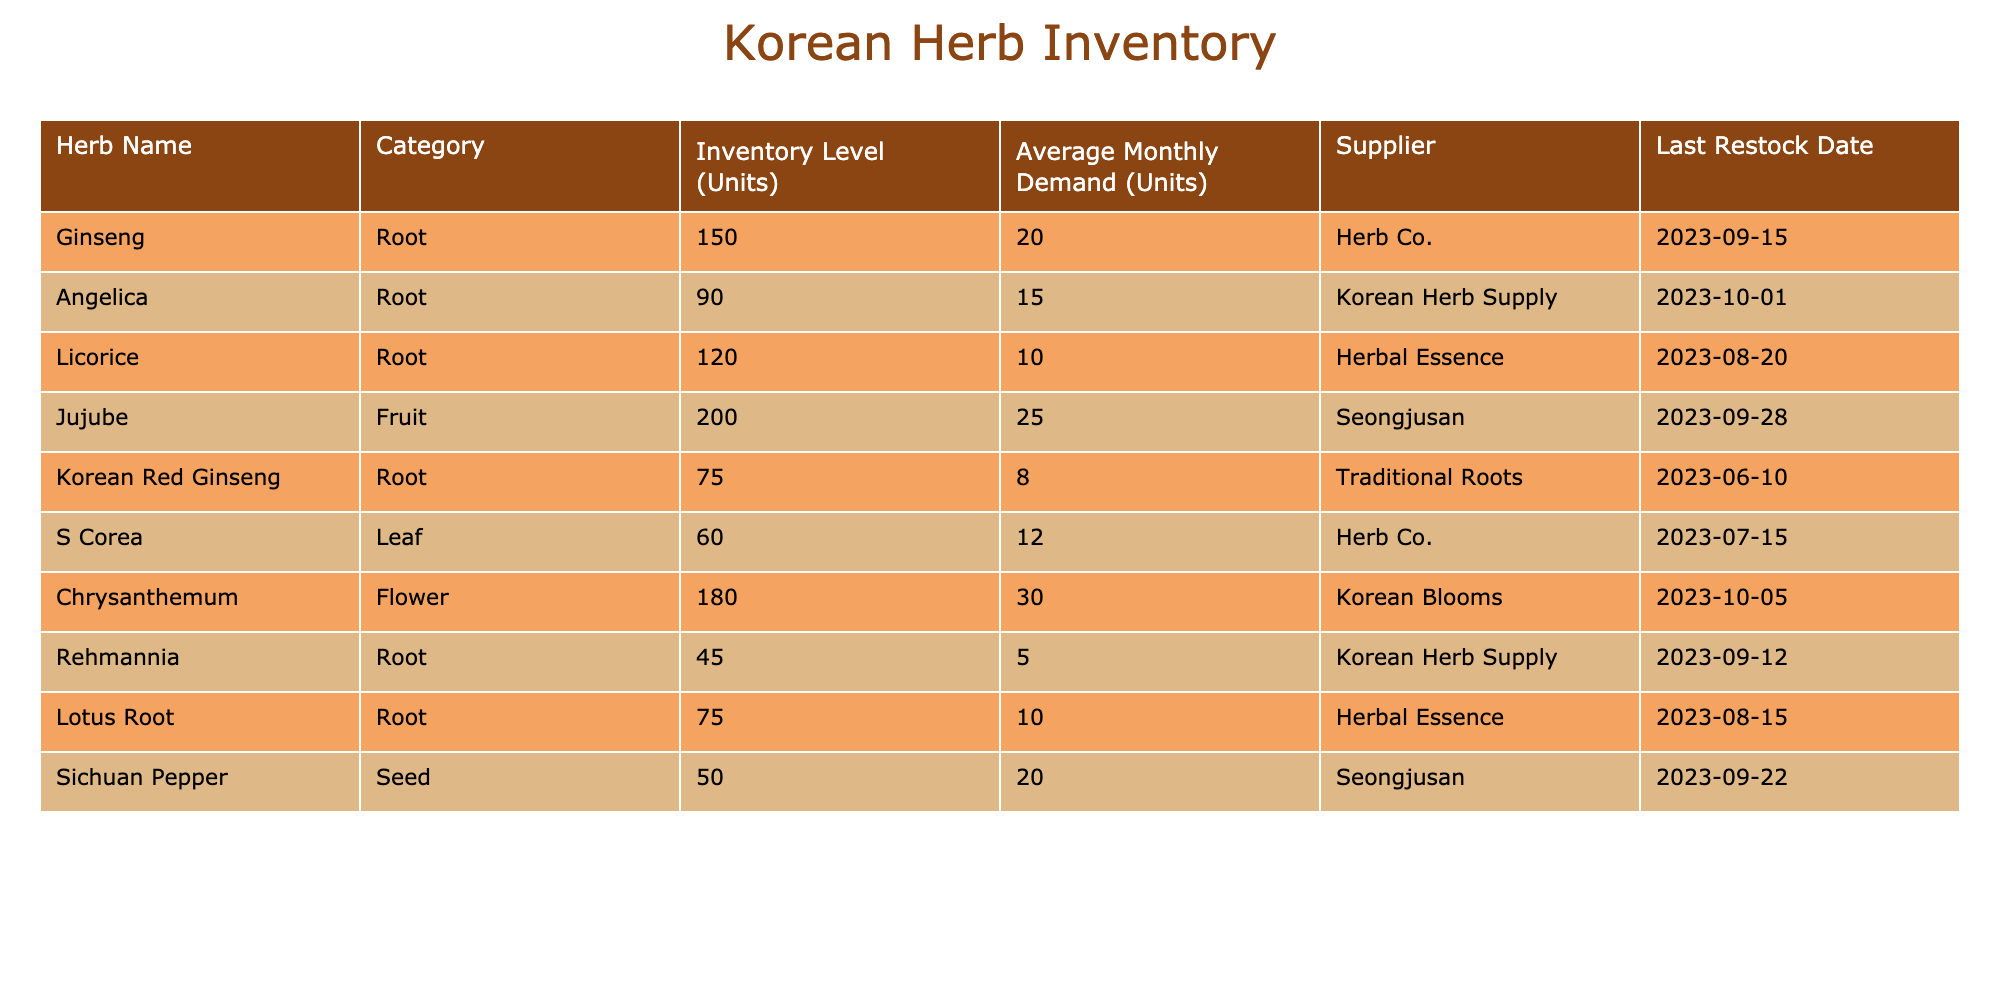What is the inventory level of Ginseng? The inventory level of Ginseng is directly provided in the table under the "Inventory Level (Units)" column for that specific herb.
Answer: 150 Which herb has the highest average monthly demand? The average monthly demand for each herb can be found in the "Average Monthly Demand (Units)" column. By comparing the values, Chrysanthemum has the highest demand at 30 units.
Answer: Chrysanthemum What is the total inventory of all root herbs? To find the total inventory of all root herbs, we need to sum the inventory levels of all herbs categorized as "Root", which are Ginseng (150), Angelica (90), Licorice (120), Korean Red Ginseng (75), Rehmannia (45), and Lotus Root (75). The total is calculated as 150 + 90 + 120 + 75 + 45 + 75 = 555.
Answer: 555 Is the last restock date for Sichuan Pepper after the last restock date of Ginseng? We check the "Last Restock Date" for both herbs: Sichuan Pepper was restocked on 2023-09-22, while Ginseng was restocked on 2023-09-15. Since 2023-09-22 comes after 2023-09-15, the statement is true.
Answer: Yes What is the average inventory level of the fruit and seed categories combined? First, identify the inventory levels for the "Fruit" category (Jujube = 200) and "Seed" category (Sichuan Pepper = 50). To find the average, add these two values: 200 + 50 = 250, and then divide by the number of categories involved (2): 250 / 2 = 125.
Answer: 125 What herb has the lowest inventory level and what is that level? By reviewing the "Inventory Level (Units)" column, we find that Rehmannia has the lowest inventory level at 45 units among all listed herbs.
Answer: Rehmannia, 45 How many units of inventory are available for herbs that have a monthly demand of less than 10? The relevant herbs with monthly demand less than 10, identified in the table, are Korean Red Ginseng (75) and Rehmannia (45). Adding their inventory levels: 75 + 45 = 120.
Answer: 120 Is the inventory level of Licorice greater than that of Korean Red Ginseng? By comparing the two values: Licorice has an inventory level of 120, while Korean Red Ginseng has 75. Since 120 is greater than 75, the answer is affirmative.
Answer: Yes What is the difference in inventory levels between the herb with the highest inventory and the herb with the lowest inventory? The herb with the highest inventory is Jujube with 200 units, and the lowest is Rehmannia with 45 units. The difference is calculated as 200 - 45 = 155.
Answer: 155 